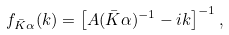<formula> <loc_0><loc_0><loc_500><loc_500>f _ { \bar { K } \alpha } ( k ) = \left [ A ( \bar { K } \alpha ) ^ { - 1 } - i k \right ] ^ { - 1 } ,</formula> 